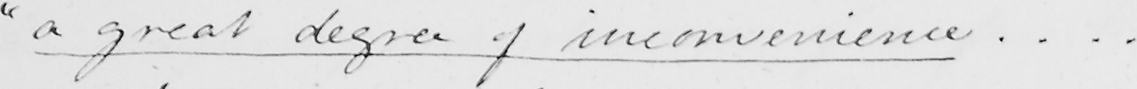Please transcribe the handwritten text in this image. " a great degree of inconvenience ... . 